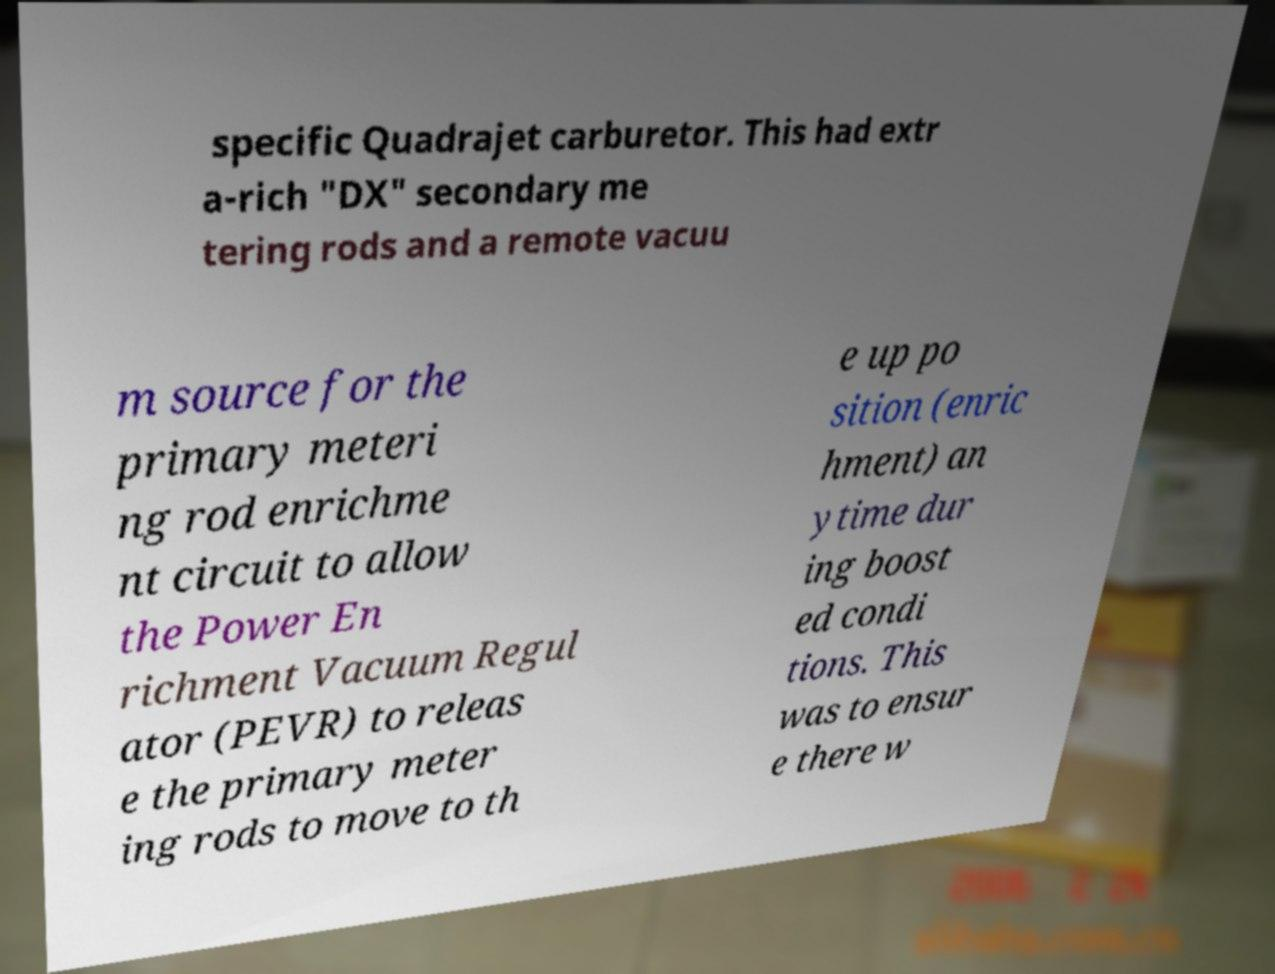There's text embedded in this image that I need extracted. Can you transcribe it verbatim? specific Quadrajet carburetor. This had extr a-rich "DX" secondary me tering rods and a remote vacuu m source for the primary meteri ng rod enrichme nt circuit to allow the Power En richment Vacuum Regul ator (PEVR) to releas e the primary meter ing rods to move to th e up po sition (enric hment) an ytime dur ing boost ed condi tions. This was to ensur e there w 